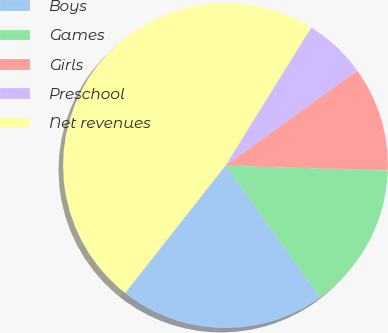Convert chart. <chart><loc_0><loc_0><loc_500><loc_500><pie_chart><fcel>Boys<fcel>Games<fcel>Girls<fcel>Preschool<fcel>Net revenues<nl><fcel>20.5%<fcel>14.62%<fcel>10.42%<fcel>6.22%<fcel>48.23%<nl></chart> 